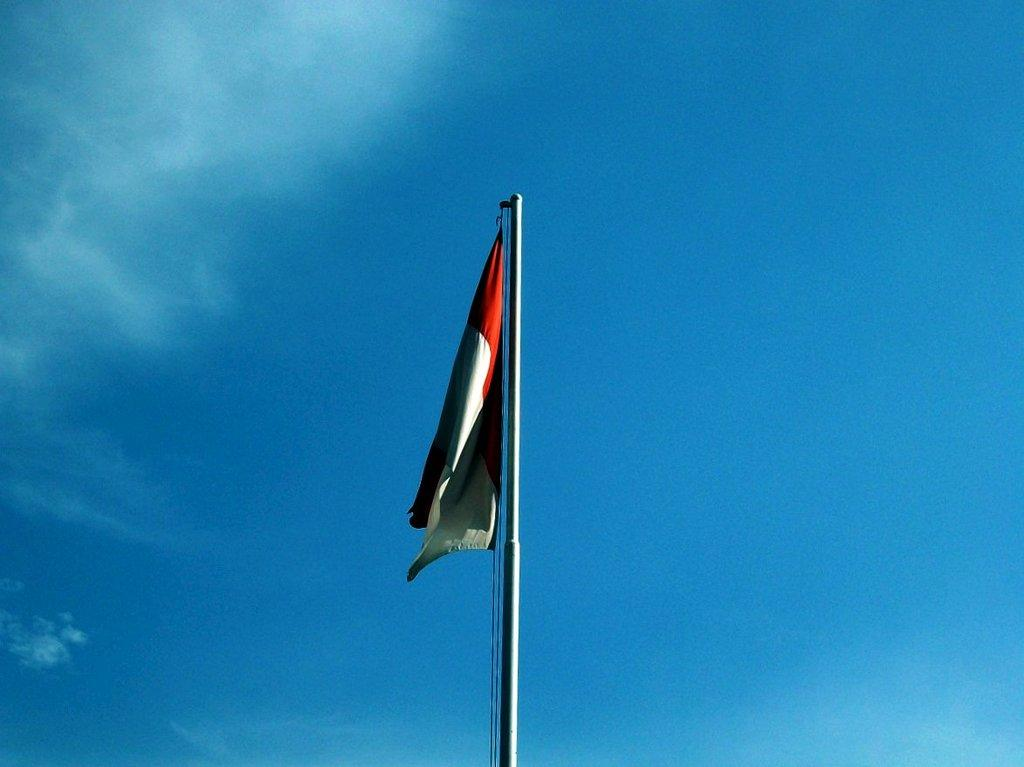What is the main object in the center of the image? There is a pole with a flag and rope in the center of the image. What can be seen in the background of the image? There are clouds in the sky in the background of the image. How many houses are visible in the image? There are no houses visible in the image; it only features a pole with a flag and rope, and clouds in the sky. 